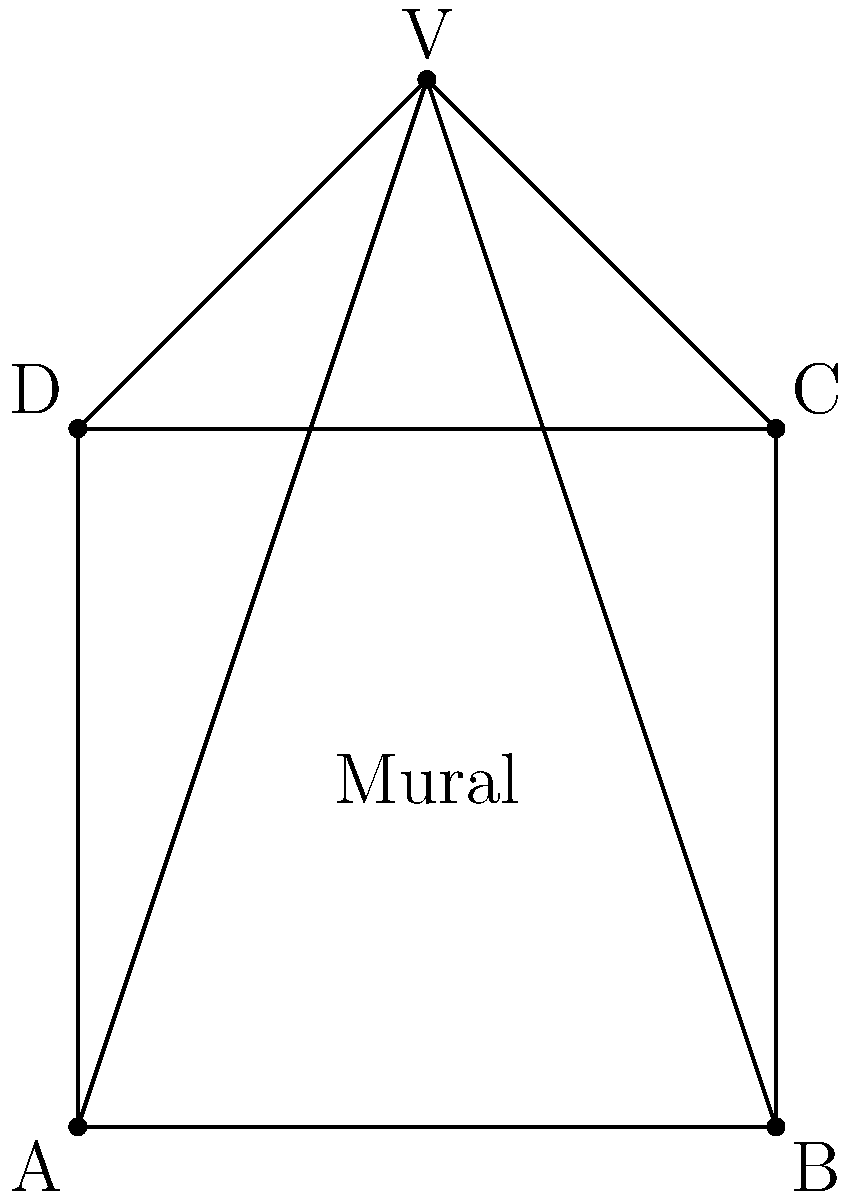In Diego Rivera's mural "Detroit Industry Murals," how does the use of a single vanishing point contribute to the nationalistic narrative of Mexican labor and industry? Consider the diagram above as a simplified representation of the mural's perspective. To answer this question, we need to consider the following steps:

1. Understand the concept of vanishing point:
   - In the diagram, point V represents the vanishing point.
   - All parallel lines in the mural converge at this point.

2. Analyze the effect of a single vanishing point:
   - It creates a strong sense of depth and focus.
   - The viewer's eye is naturally drawn to this point.

3. Consider Rivera's nationalistic narrative:
   - The single vanishing point can symbolize a unified vision of Mexican labor and industry.
   - It creates a sense of order and purpose in the depiction of workers and machinery.

4. Examine the visual hierarchy:
   - Elements closer to the foreground (bottom of the mural) appear larger and more detailed.
   - This can emphasize the importance of individual workers and their contributions.

5. Interpret the perspective in relation to Mexican identity:
   - The converging lines can represent the coming together of diverse elements of Mexican society.
   - The vanishing point might symbolize a shared goal or future for the nation.

6. Consider the emotional impact:
   - The strong perspective creates a sense of monumentality and importance.
   - This aligns with Rivera's aim to elevate the status of Mexican workers and industry.

By using a single vanishing point, Rivera creates a powerful visual structure that supports his nationalistic narrative, emphasizing unity, progress, and the dignity of Mexican labor.
Answer: The single vanishing point creates visual unity and focus, emphasizing the collective strength and shared vision of Mexican labor and industry in Rivera's nationalistic narrative. 